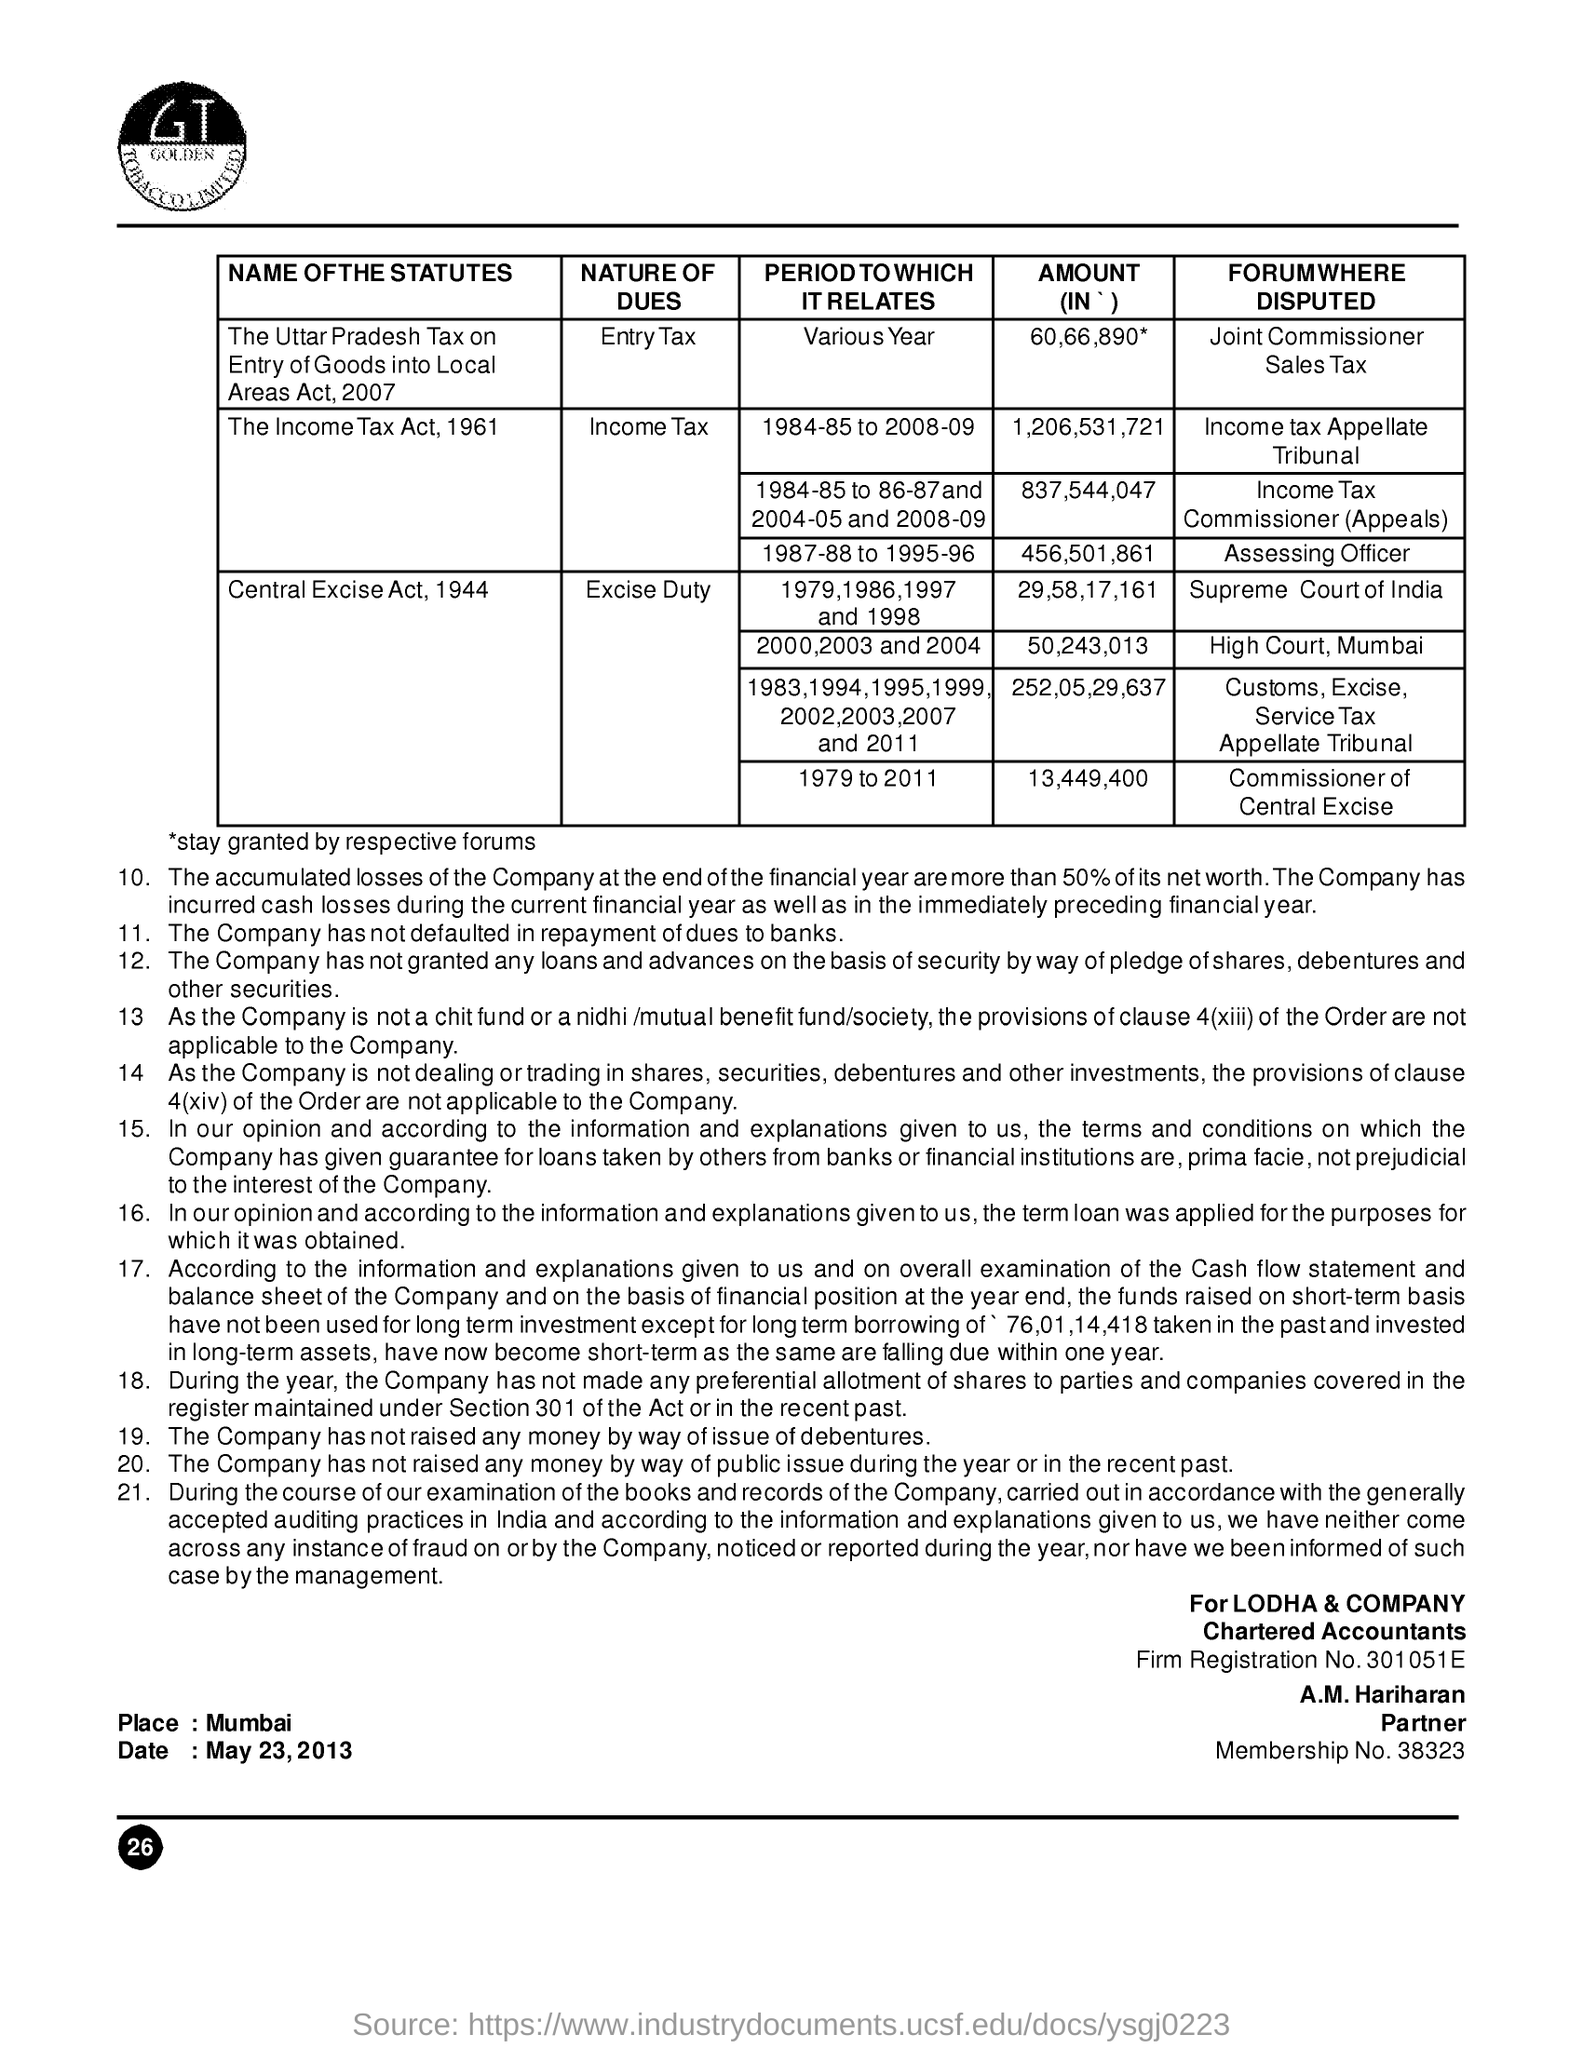Specify some key components in this picture. The name of the partner is A.M Hariharan. The amount of income tax disputed by a forum from the assessing officer is 456,501,861. The place name mentioned is Mumbai. The amount of the Central Excise Act, 1994 distributed by the Supreme Court of India is 29,58,17,161. The firm registration number is 301051E.. 